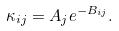Convert formula to latex. <formula><loc_0><loc_0><loc_500><loc_500>\kappa _ { i j } = A _ { j } e ^ { - B _ { i j } } .</formula> 